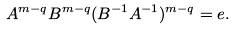<formula> <loc_0><loc_0><loc_500><loc_500>A ^ { m - q } B ^ { m - q } ( B ^ { - 1 } A ^ { - 1 } ) ^ { m - q } = e .</formula> 